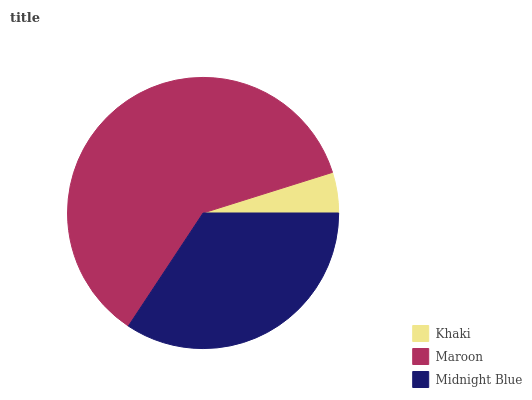Is Khaki the minimum?
Answer yes or no. Yes. Is Maroon the maximum?
Answer yes or no. Yes. Is Midnight Blue the minimum?
Answer yes or no. No. Is Midnight Blue the maximum?
Answer yes or no. No. Is Maroon greater than Midnight Blue?
Answer yes or no. Yes. Is Midnight Blue less than Maroon?
Answer yes or no. Yes. Is Midnight Blue greater than Maroon?
Answer yes or no. No. Is Maroon less than Midnight Blue?
Answer yes or no. No. Is Midnight Blue the high median?
Answer yes or no. Yes. Is Midnight Blue the low median?
Answer yes or no. Yes. Is Khaki the high median?
Answer yes or no. No. Is Maroon the low median?
Answer yes or no. No. 